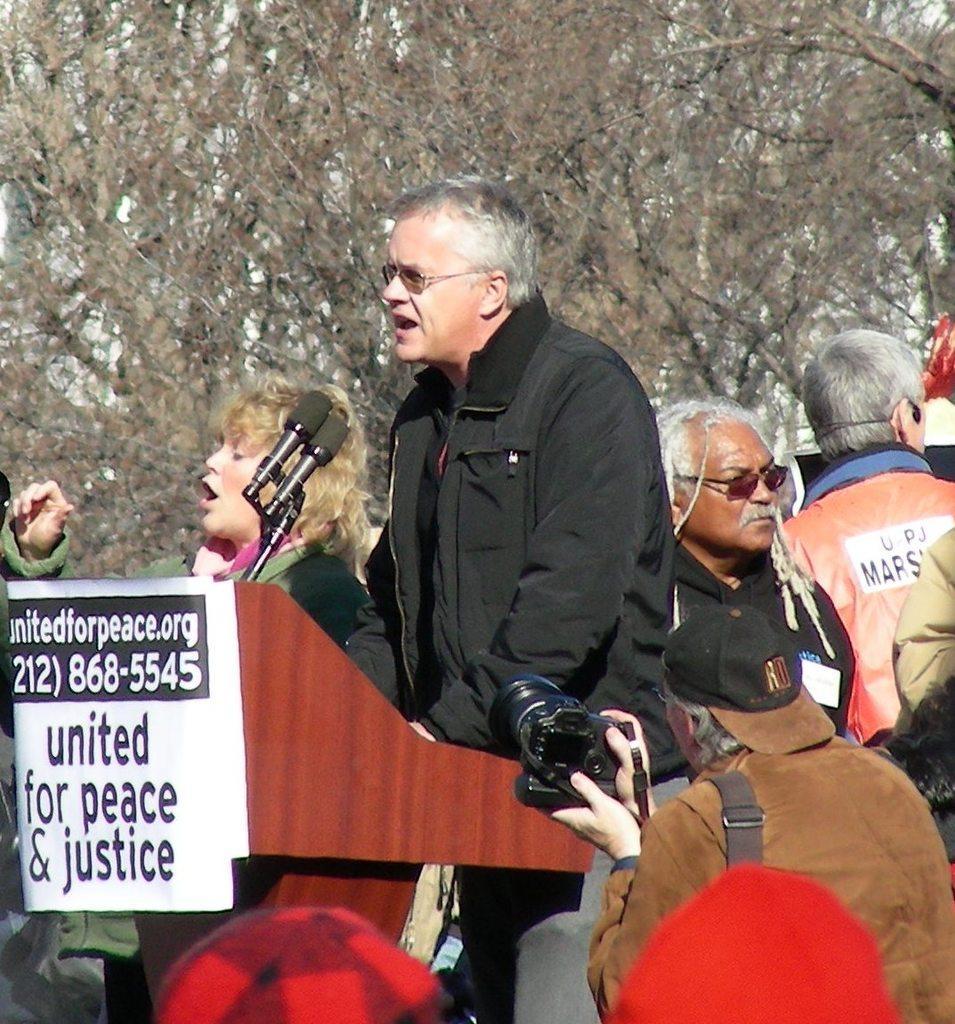Please provide a concise description of this image. In this image there is a person standing in front of the dais. On top of the days there are mike's. Around him there are a few other people standing. There is a poster with some text on it. In the background of the image there are trees. 